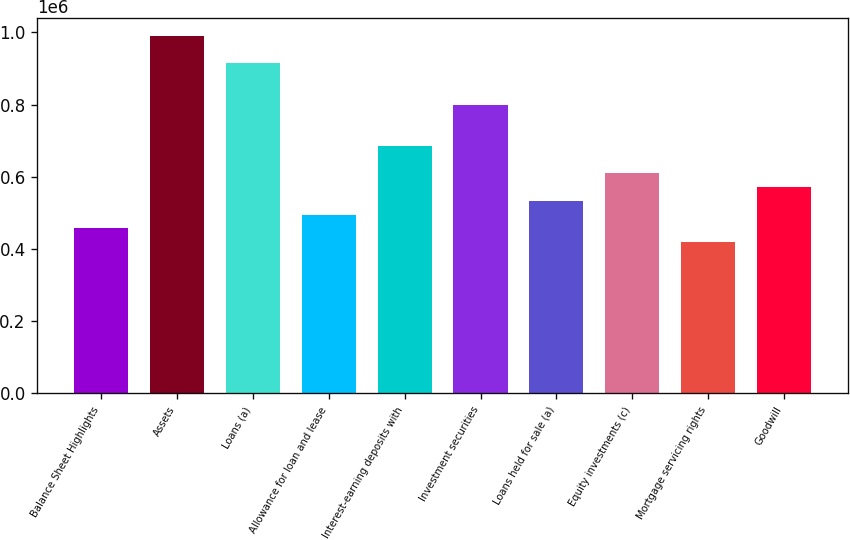Convert chart to OTSL. <chart><loc_0><loc_0><loc_500><loc_500><bar_chart><fcel>Balance Sheet Highlights<fcel>Assets<fcel>Loans (a)<fcel>Allowance for loan and lease<fcel>Interest-earning deposits with<fcel>Investment securities<fcel>Loans held for sale (a)<fcel>Equity investments (c)<fcel>Mortgage servicing rights<fcel>Goodwill<nl><fcel>456921<fcel>989995<fcel>913841<fcel>494998<fcel>685381<fcel>799611<fcel>533075<fcel>609228<fcel>418845<fcel>571151<nl></chart> 